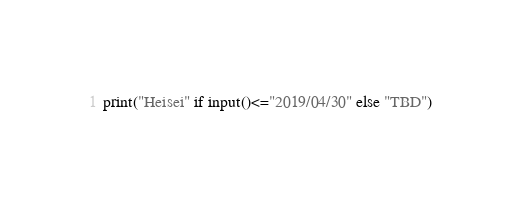<code> <loc_0><loc_0><loc_500><loc_500><_Python_>print("Heisei" if input()<="2019/04/30" else "TBD")</code> 